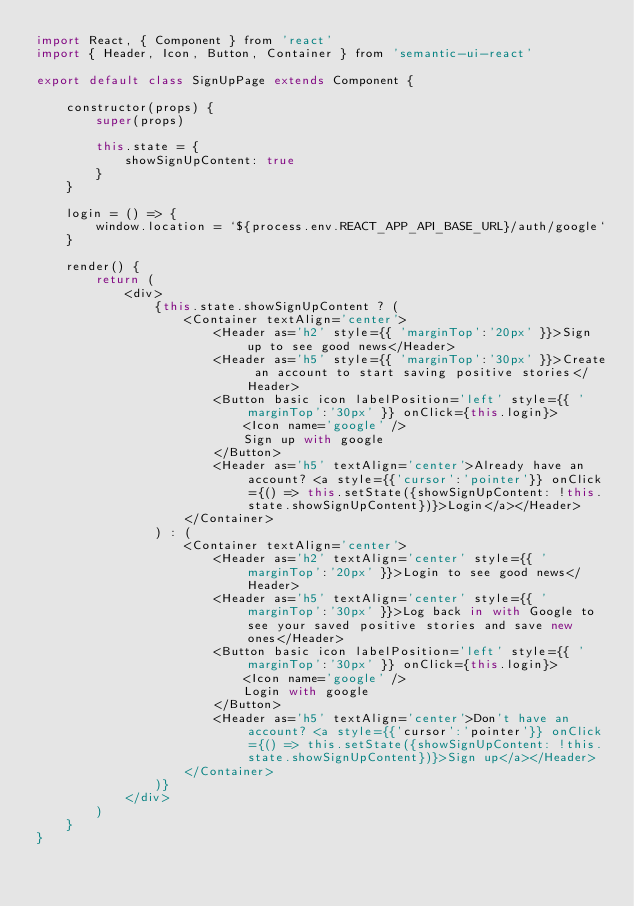Convert code to text. <code><loc_0><loc_0><loc_500><loc_500><_JavaScript_>import React, { Component } from 'react'
import { Header, Icon, Button, Container } from 'semantic-ui-react'

export default class SignUpPage extends Component {

    constructor(props) {
        super(props)

        this.state = {
            showSignUpContent: true
        }
    }

    login = () => {
        window.location = `${process.env.REACT_APP_API_BASE_URL}/auth/google`
    }

    render() {
        return (
            <div>
                {this.state.showSignUpContent ? (
                    <Container textAlign='center'>
                        <Header as='h2' style={{ 'marginTop':'20px' }}>Sign up to see good news</Header>
                        <Header as='h5' style={{ 'marginTop':'30px' }}>Create an account to start saving positive stories</Header>
                        <Button basic icon labelPosition='left' style={{ 'marginTop':'30px' }} onClick={this.login}>
                            <Icon name='google' />
                            Sign up with google
                        </Button>
                        <Header as='h5' textAlign='center'>Already have an account? <a style={{'cursor':'pointer'}} onClick={() => this.setState({showSignUpContent: !this.state.showSignUpContent})}>Login</a></Header>
                    </Container>
                ) : (
                    <Container textAlign='center'>
                        <Header as='h2' textAlign='center' style={{ 'marginTop':'20px' }}>Login to see good news</Header>
                        <Header as='h5' textAlign='center' style={{ 'marginTop':'30px' }}>Log back in with Google to see your saved positive stories and save new ones</Header>
                        <Button basic icon labelPosition='left' style={{ 'marginTop':'30px' }} onClick={this.login}>
                            <Icon name='google' />
                            Login with google
                        </Button>
                        <Header as='h5' textAlign='center'>Don't have an account? <a style={{'cursor':'pointer'}} onClick={() => this.setState({showSignUpContent: !this.state.showSignUpContent})}>Sign up</a></Header>
                    </Container>
                )}
            </div>
        )
    }
}</code> 